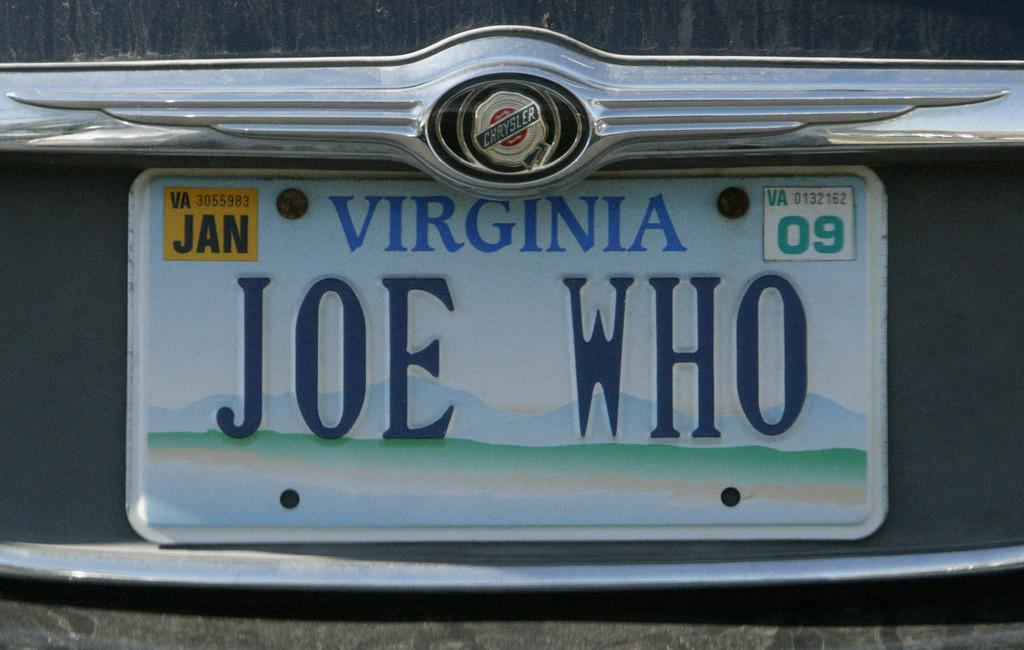<image>
Offer a succinct explanation of the picture presented. Joe Who is a driver who is licensded in Virginia. 